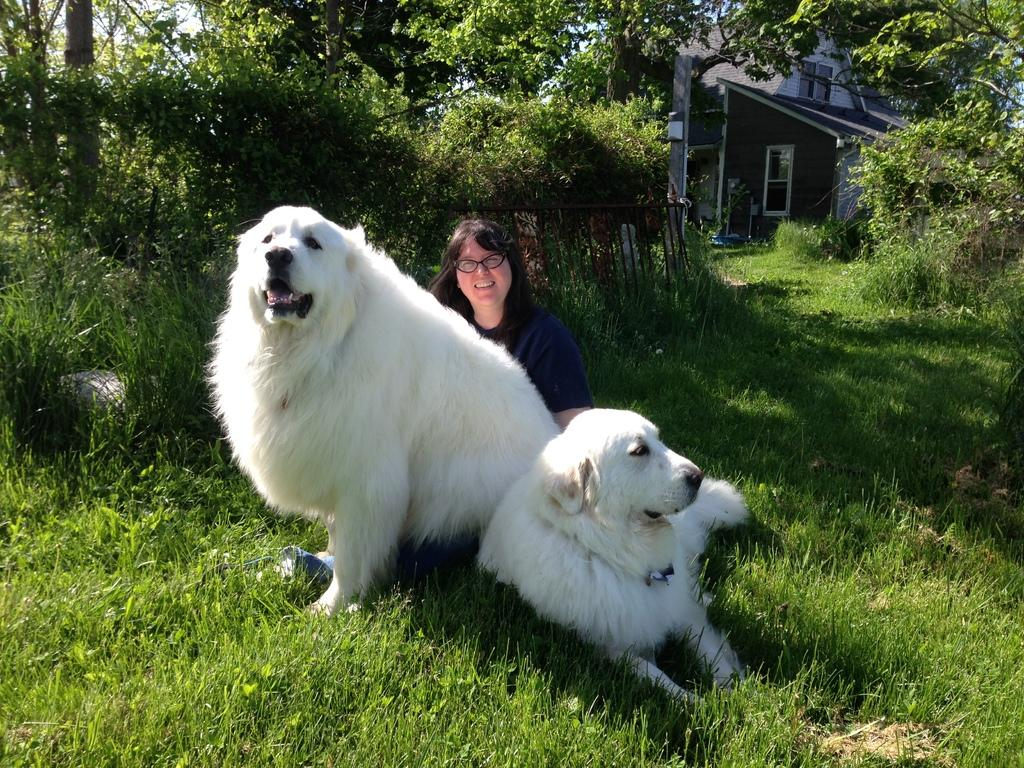What type of living organisms can be seen in the image? Plants and trees are visible in the image. Are there any animals present in the image? Yes, there are dogs in front of a person in the image. What type of structure can be seen in the top right of the image? There is a house in the top right of the image. What type of spring can be seen in the image? There is no spring present in the image. Is there a writer in the image? There is no mention of a writer or any writing activity in the image. 